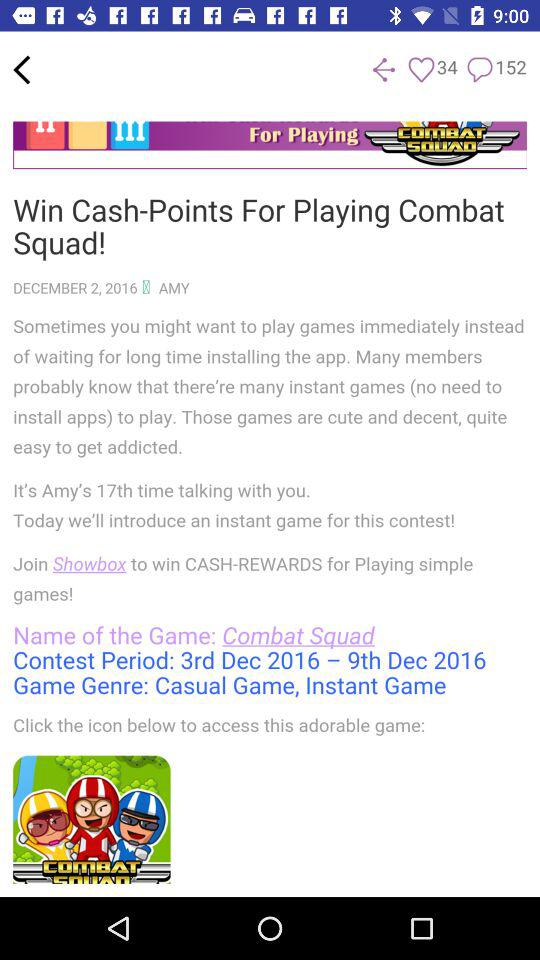What is the period of the contest? The period of the contest is from December 3, 2016 to December 9, 2016. 